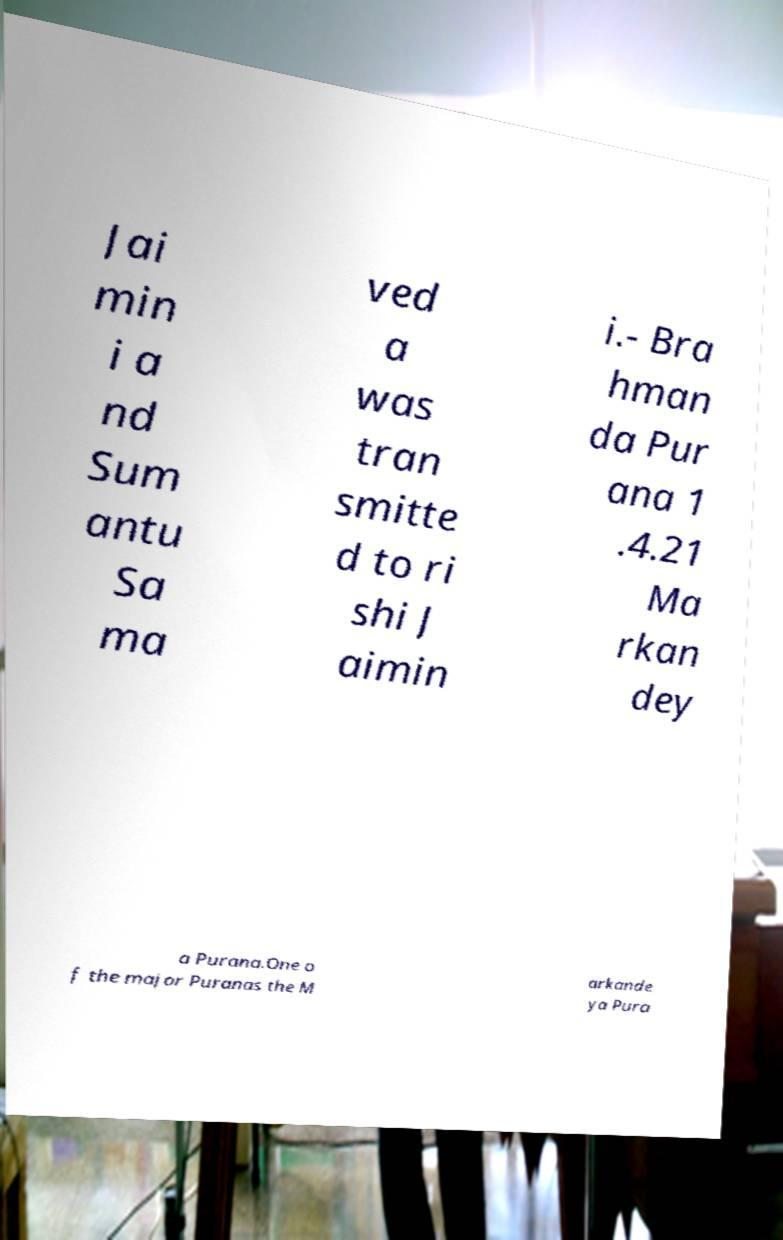Can you accurately transcribe the text from the provided image for me? Jai min i a nd Sum antu Sa ma ved a was tran smitte d to ri shi J aimin i.- Bra hman da Pur ana 1 .4.21 Ma rkan dey a Purana.One o f the major Puranas the M arkande ya Pura 